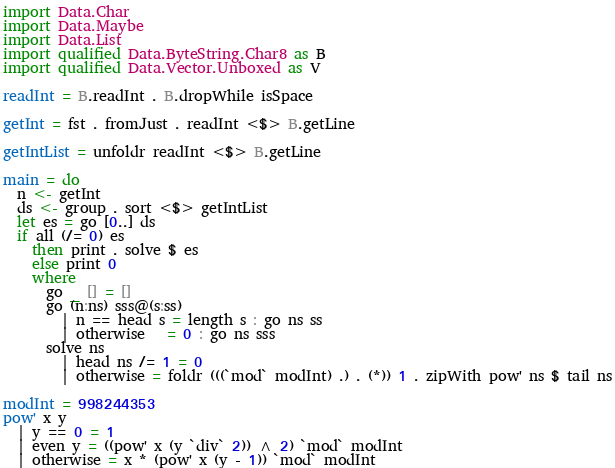Convert code to text. <code><loc_0><loc_0><loc_500><loc_500><_Haskell_>import Data.Char
import Data.Maybe
import Data.List
import qualified Data.ByteString.Char8 as B
import qualified Data.Vector.Unboxed as V

readInt = B.readInt . B.dropWhile isSpace

getInt = fst . fromJust . readInt <$> B.getLine

getIntList = unfoldr readInt <$> B.getLine

main = do
  n <- getInt
  ds <- group . sort <$> getIntList
  let es = go [0..] ds
  if all (/= 0) es
    then print . solve $ es
    else print 0
    where
      go _ [] = []
      go (n:ns) sss@(s:ss)
        | n == head s = length s : go ns ss
        | otherwise   = 0 : go ns sss
      solve ns
        | head ns /= 1 = 0
        | otherwise = foldr (((`mod` modInt) .) . (*)) 1 . zipWith pow' ns $ tail ns

modInt = 998244353
pow' x y
  | y == 0 = 1
  | even y = ((pow' x (y `div` 2)) ^ 2) `mod` modInt
  | otherwise = x * (pow' x (y - 1)) `mod` modInt
</code> 